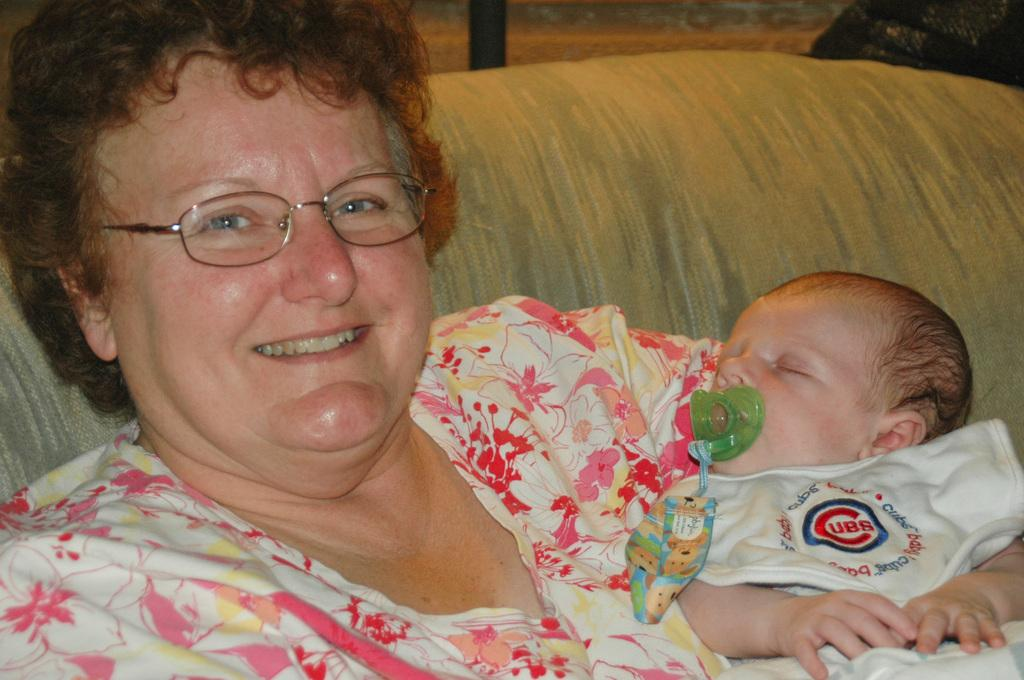Where was the image taken? The image is taken indoors. What can be seen in the background of the image? There is a window in the background of the image. What is the woman in the image doing? The woman is holding a baby in her hands. Where is the woman sitting in the image? The woman is sitting on a couch. What type of pancake can be seen on the mountain in the image? There is no pancake or mountain present in the image; it features a woman holding a baby indoors. 